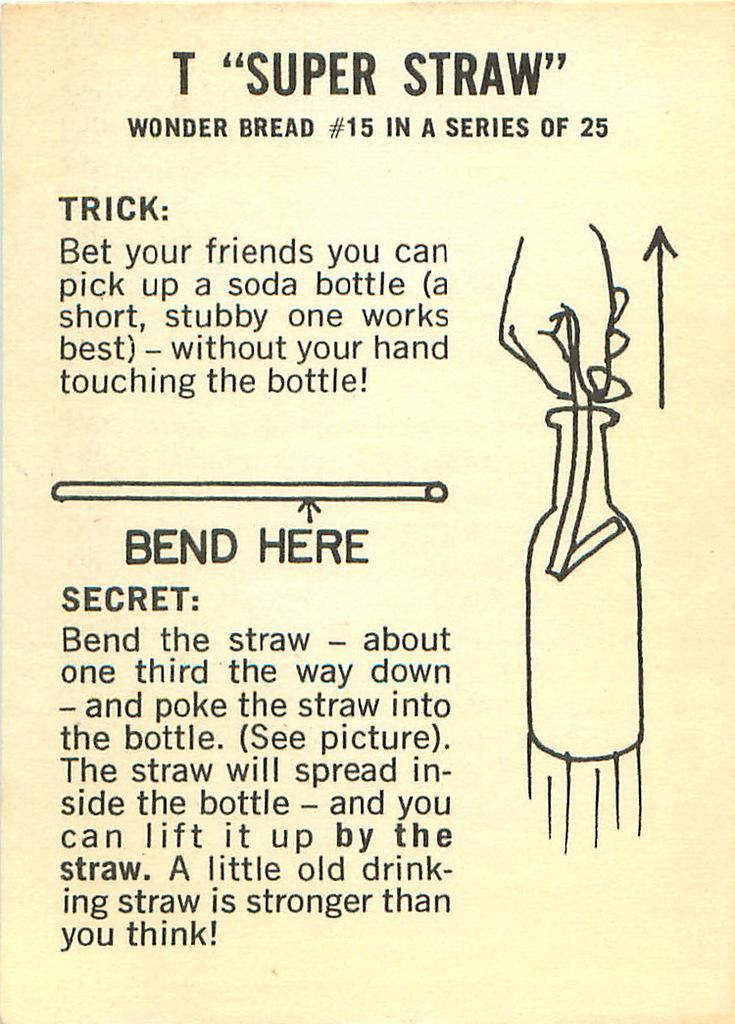<image>
Create a compact narrative representing the image presented. A pamphlet with instructions on how to use a super straw. 